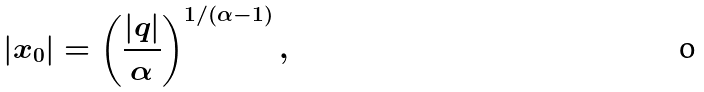<formula> <loc_0><loc_0><loc_500><loc_500>| x _ { 0 } | = \left ( \frac { | q | } { \alpha } \right ) ^ { 1 / ( \alpha - 1 ) } ,</formula> 